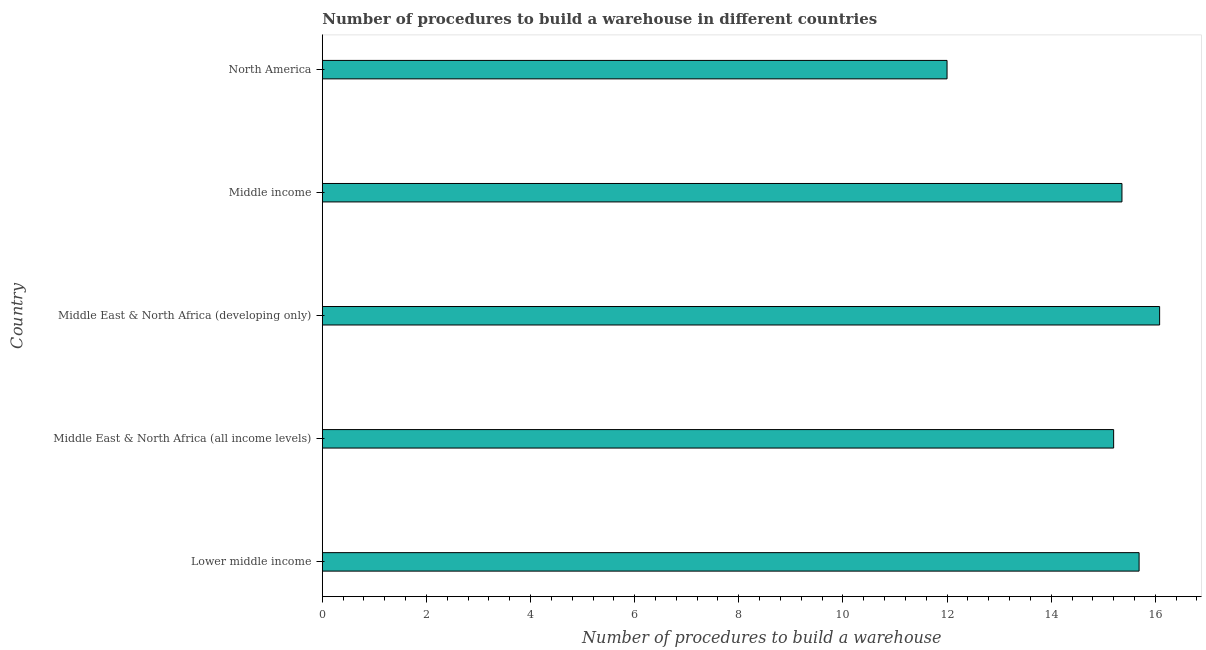Does the graph contain grids?
Keep it short and to the point. No. What is the title of the graph?
Your answer should be compact. Number of procedures to build a warehouse in different countries. What is the label or title of the X-axis?
Give a very brief answer. Number of procedures to build a warehouse. What is the number of procedures to build a warehouse in Middle income?
Keep it short and to the point. 15.36. Across all countries, what is the maximum number of procedures to build a warehouse?
Offer a very short reply. 16.08. Across all countries, what is the minimum number of procedures to build a warehouse?
Provide a succinct answer. 12. In which country was the number of procedures to build a warehouse maximum?
Offer a very short reply. Middle East & North Africa (developing only). What is the sum of the number of procedures to build a warehouse?
Make the answer very short. 74.33. What is the difference between the number of procedures to build a warehouse in Lower middle income and Middle East & North Africa (all income levels)?
Your answer should be compact. 0.49. What is the average number of procedures to build a warehouse per country?
Offer a terse response. 14.87. What is the median number of procedures to build a warehouse?
Offer a very short reply. 15.36. What is the ratio of the number of procedures to build a warehouse in Middle East & North Africa (all income levels) to that in North America?
Give a very brief answer. 1.27. Is the number of procedures to build a warehouse in Lower middle income less than that in Middle East & North Africa (all income levels)?
Give a very brief answer. No. Is the difference between the number of procedures to build a warehouse in Lower middle income and Middle East & North Africa (all income levels) greater than the difference between any two countries?
Provide a short and direct response. No. What is the difference between the highest and the second highest number of procedures to build a warehouse?
Offer a very short reply. 0.39. Is the sum of the number of procedures to build a warehouse in Middle East & North Africa (all income levels) and Middle income greater than the maximum number of procedures to build a warehouse across all countries?
Offer a terse response. Yes. What is the difference between the highest and the lowest number of procedures to build a warehouse?
Your response must be concise. 4.08. How many bars are there?
Your response must be concise. 5. Are the values on the major ticks of X-axis written in scientific E-notation?
Make the answer very short. No. What is the Number of procedures to build a warehouse of Lower middle income?
Your answer should be compact. 15.69. What is the Number of procedures to build a warehouse in Middle East & North Africa (all income levels)?
Give a very brief answer. 15.2. What is the Number of procedures to build a warehouse of Middle East & North Africa (developing only)?
Make the answer very short. 16.08. What is the Number of procedures to build a warehouse of Middle income?
Offer a terse response. 15.36. What is the difference between the Number of procedures to build a warehouse in Lower middle income and Middle East & North Africa (all income levels)?
Your answer should be very brief. 0.49. What is the difference between the Number of procedures to build a warehouse in Lower middle income and Middle East & North Africa (developing only)?
Your answer should be very brief. -0.39. What is the difference between the Number of procedures to build a warehouse in Lower middle income and Middle income?
Offer a terse response. 0.33. What is the difference between the Number of procedures to build a warehouse in Lower middle income and North America?
Offer a very short reply. 3.69. What is the difference between the Number of procedures to build a warehouse in Middle East & North Africa (all income levels) and Middle East & North Africa (developing only)?
Offer a terse response. -0.88. What is the difference between the Number of procedures to build a warehouse in Middle East & North Africa (all income levels) and Middle income?
Offer a terse response. -0.16. What is the difference between the Number of procedures to build a warehouse in Middle East & North Africa (developing only) and Middle income?
Provide a succinct answer. 0.72. What is the difference between the Number of procedures to build a warehouse in Middle East & North Africa (developing only) and North America?
Give a very brief answer. 4.08. What is the difference between the Number of procedures to build a warehouse in Middle income and North America?
Give a very brief answer. 3.36. What is the ratio of the Number of procedures to build a warehouse in Lower middle income to that in Middle East & North Africa (all income levels)?
Keep it short and to the point. 1.03. What is the ratio of the Number of procedures to build a warehouse in Lower middle income to that in Middle East & North Africa (developing only)?
Offer a very short reply. 0.97. What is the ratio of the Number of procedures to build a warehouse in Lower middle income to that in North America?
Your answer should be very brief. 1.31. What is the ratio of the Number of procedures to build a warehouse in Middle East & North Africa (all income levels) to that in Middle East & North Africa (developing only)?
Your answer should be very brief. 0.94. What is the ratio of the Number of procedures to build a warehouse in Middle East & North Africa (all income levels) to that in Middle income?
Your answer should be compact. 0.99. What is the ratio of the Number of procedures to build a warehouse in Middle East & North Africa (all income levels) to that in North America?
Keep it short and to the point. 1.27. What is the ratio of the Number of procedures to build a warehouse in Middle East & North Africa (developing only) to that in Middle income?
Provide a short and direct response. 1.05. What is the ratio of the Number of procedures to build a warehouse in Middle East & North Africa (developing only) to that in North America?
Your answer should be very brief. 1.34. What is the ratio of the Number of procedures to build a warehouse in Middle income to that in North America?
Your response must be concise. 1.28. 